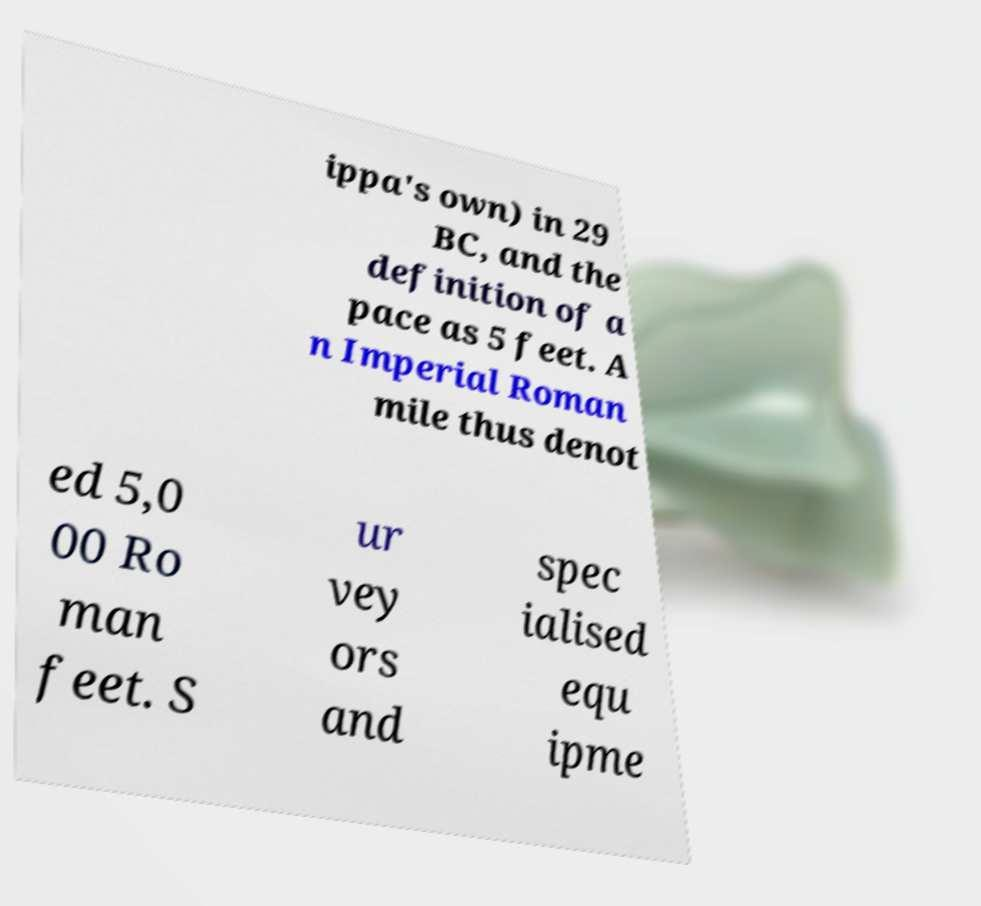There's text embedded in this image that I need extracted. Can you transcribe it verbatim? ippa's own) in 29 BC, and the definition of a pace as 5 feet. A n Imperial Roman mile thus denot ed 5,0 00 Ro man feet. S ur vey ors and spec ialised equ ipme 